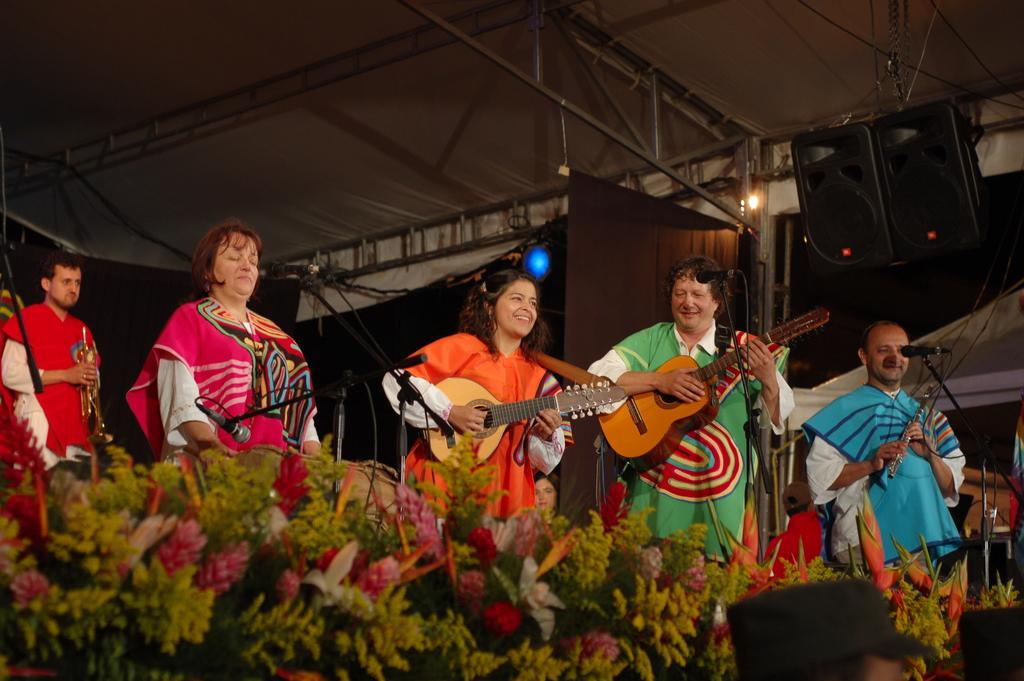In one or two sentences, can you explain what this image depicts? In this picture we can see some persons are standing and playing guitar. This is the mike, and these are some flowers. On the background there is a light. And this is the roof. 